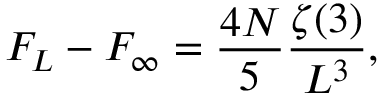Convert formula to latex. <formula><loc_0><loc_0><loc_500><loc_500>F _ { L } - F _ { \infty } = { \frac { 4 N } { 5 } } { \frac { \zeta ( 3 ) } { L ^ { 3 } } } ,</formula> 